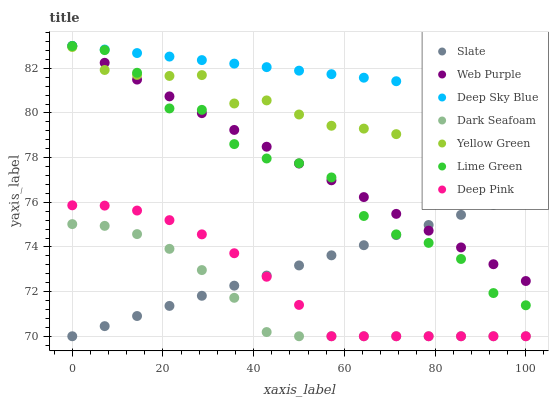Does Dark Seafoam have the minimum area under the curve?
Answer yes or no. Yes. Does Deep Sky Blue have the maximum area under the curve?
Answer yes or no. Yes. Does Yellow Green have the minimum area under the curve?
Answer yes or no. No. Does Yellow Green have the maximum area under the curve?
Answer yes or no. No. Is Web Purple the smoothest?
Answer yes or no. Yes. Is Lime Green the roughest?
Answer yes or no. Yes. Is Yellow Green the smoothest?
Answer yes or no. No. Is Yellow Green the roughest?
Answer yes or no. No. Does Deep Pink have the lowest value?
Answer yes or no. Yes. Does Yellow Green have the lowest value?
Answer yes or no. No. Does Lime Green have the highest value?
Answer yes or no. Yes. Does Yellow Green have the highest value?
Answer yes or no. No. Is Dark Seafoam less than Web Purple?
Answer yes or no. Yes. Is Web Purple greater than Deep Pink?
Answer yes or no. Yes. Does Dark Seafoam intersect Slate?
Answer yes or no. Yes. Is Dark Seafoam less than Slate?
Answer yes or no. No. Is Dark Seafoam greater than Slate?
Answer yes or no. No. Does Dark Seafoam intersect Web Purple?
Answer yes or no. No. 